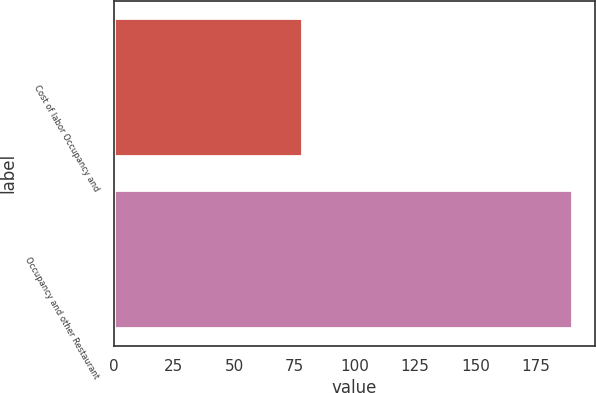Convert chart to OTSL. <chart><loc_0><loc_0><loc_500><loc_500><bar_chart><fcel>Cost of labor Occupancy and<fcel>Occupancy and other Restaurant<nl><fcel>78<fcel>190<nl></chart> 